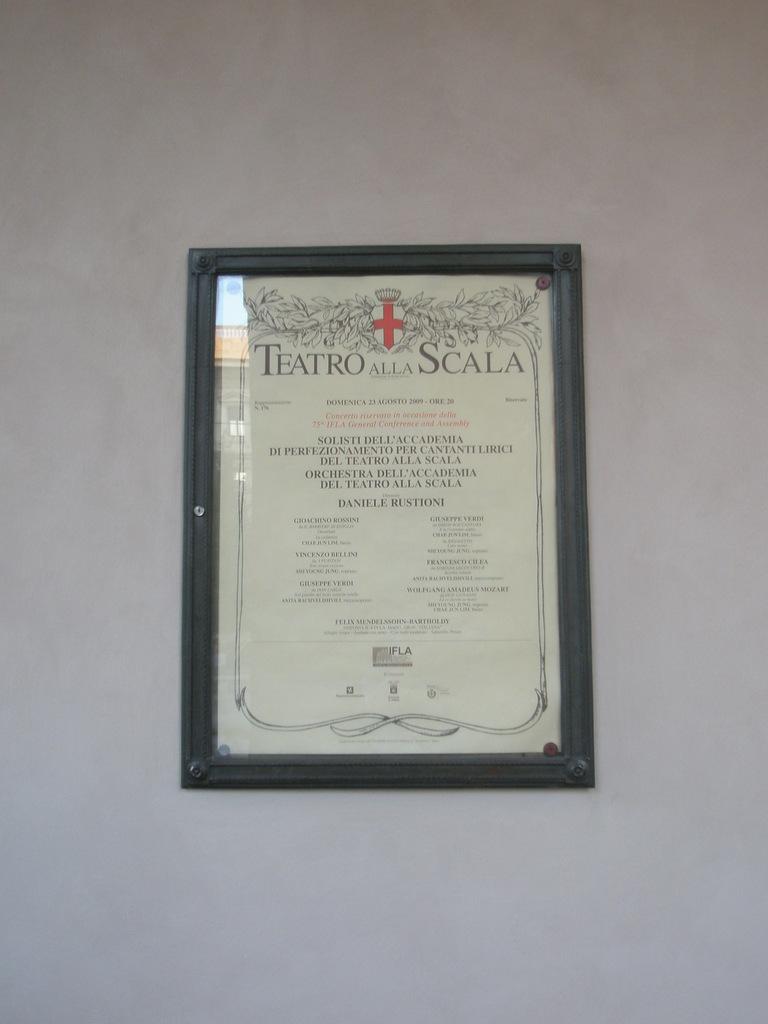What is the title of the framed certificate?
Your answer should be compact. Teatro alla scala. 